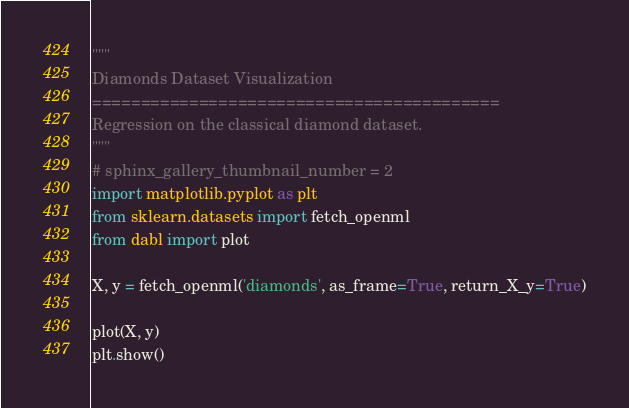Convert code to text. <code><loc_0><loc_0><loc_500><loc_500><_Python_>"""
Diamonds Dataset Visualization
==========================================
Regression on the classical diamond dataset.
"""
# sphinx_gallery_thumbnail_number = 2
import matplotlib.pyplot as plt
from sklearn.datasets import fetch_openml
from dabl import plot

X, y = fetch_openml('diamonds', as_frame=True, return_X_y=True)

plot(X, y)
plt.show()
</code> 